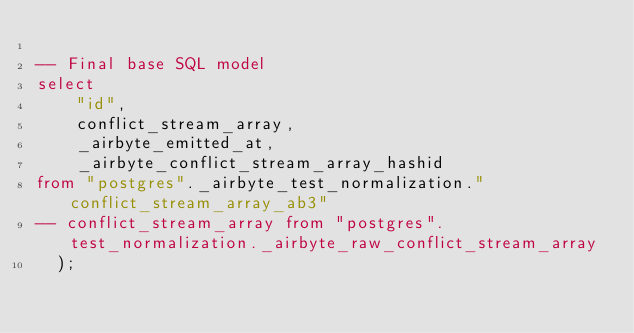<code> <loc_0><loc_0><loc_500><loc_500><_SQL_>    
-- Final base SQL model
select
    "id",
    conflict_stream_array,
    _airbyte_emitted_at,
    _airbyte_conflict_stream_array_hashid
from "postgres"._airbyte_test_normalization."conflict_stream_array_ab3"
-- conflict_stream_array from "postgres".test_normalization._airbyte_raw_conflict_stream_array
  );</code> 